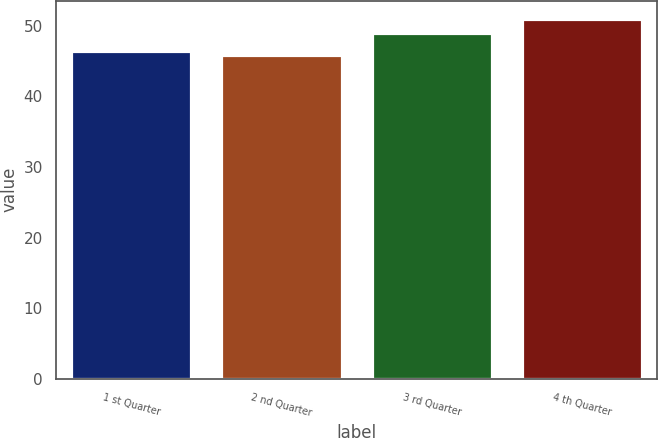Convert chart to OTSL. <chart><loc_0><loc_0><loc_500><loc_500><bar_chart><fcel>1 st Quarter<fcel>2 nd Quarter<fcel>3 rd Quarter<fcel>4 th Quarter<nl><fcel>46.45<fcel>45.83<fcel>48.94<fcel>51.03<nl></chart> 